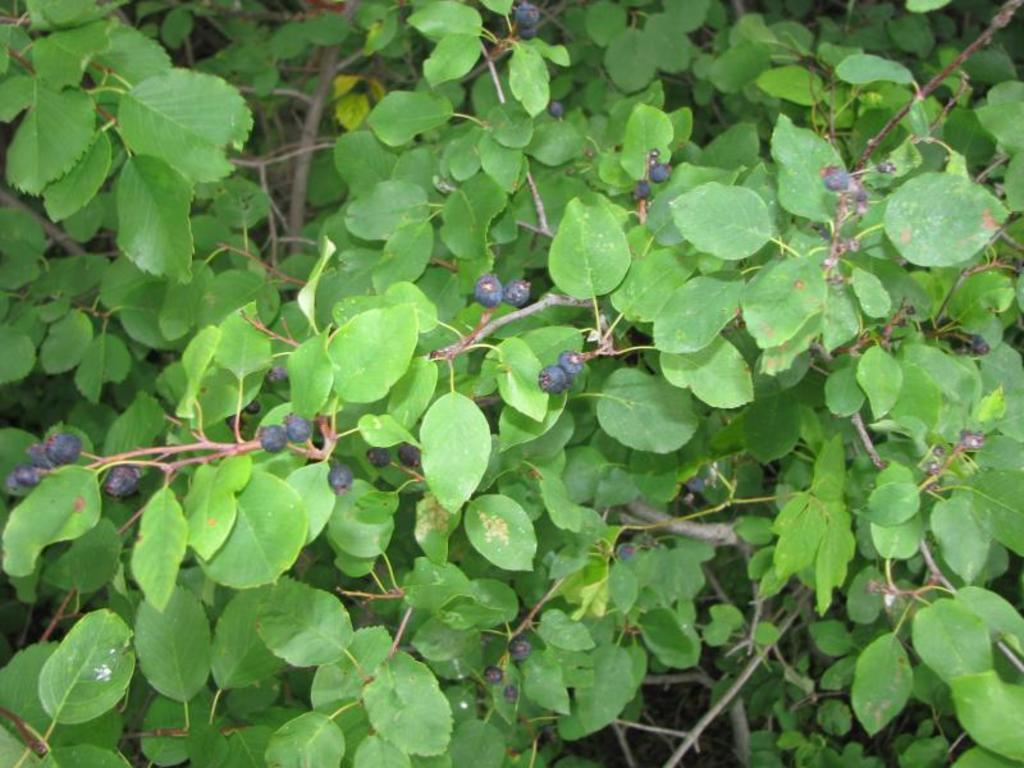What type of food can be seen in the image? There are fruits in the image. What part of the plant is visible in the image? There are leaves and stems in the image. What type of ornament is hanging from the icicle in the image? There is no icicle or ornament present in the image; it features fruits, leaves, and stems. 